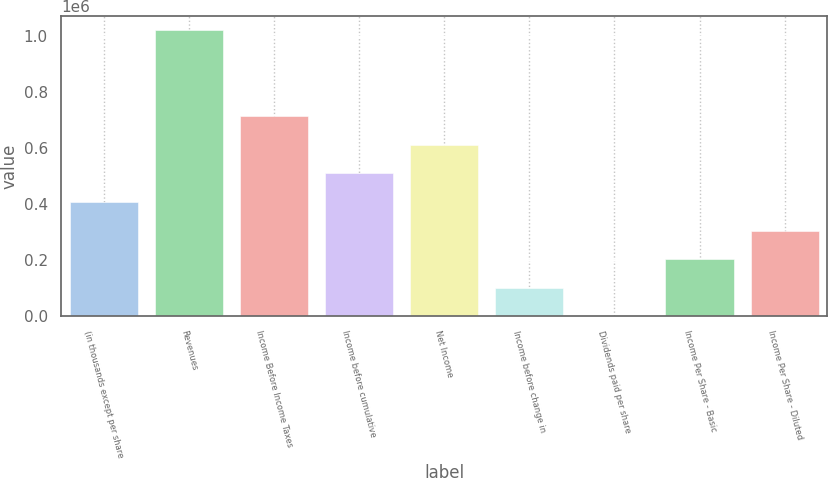<chart> <loc_0><loc_0><loc_500><loc_500><bar_chart><fcel>(in thousands except per share<fcel>Revenues<fcel>Income Before Income Taxes<fcel>Income before cumulative<fcel>Net Income<fcel>Income before change in<fcel>Dividends paid per share<fcel>Income Per Share - Basic<fcel>Income Per Share - Diluted<nl><fcel>408226<fcel>1.02056e+06<fcel>714395<fcel>510282<fcel>612338<fcel>102057<fcel>0.25<fcel>204113<fcel>306169<nl></chart> 